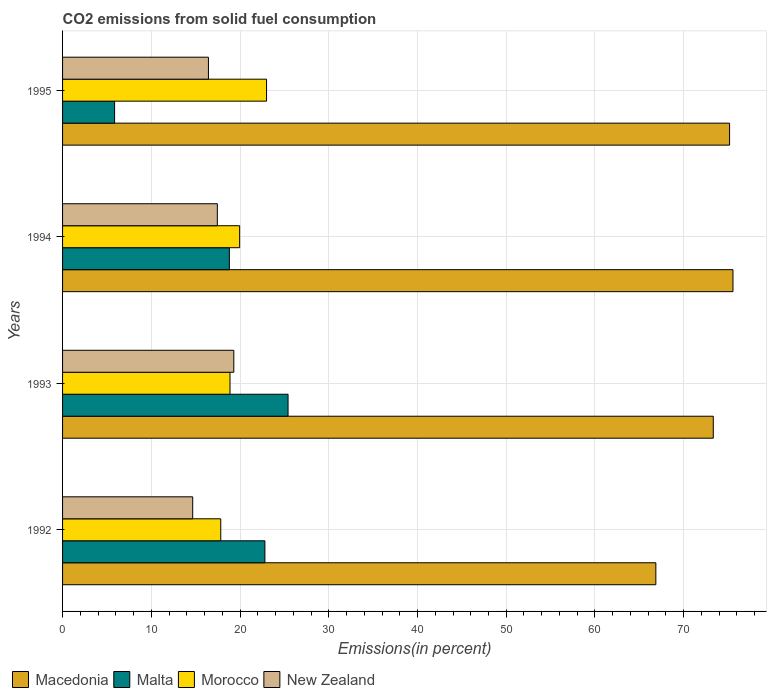How many different coloured bars are there?
Provide a succinct answer. 4. What is the total CO2 emitted in New Zealand in 1992?
Provide a short and direct response. 14.67. Across all years, what is the maximum total CO2 emitted in Morocco?
Provide a short and direct response. 22.99. Across all years, what is the minimum total CO2 emitted in Morocco?
Give a very brief answer. 17.83. In which year was the total CO2 emitted in Morocco minimum?
Your answer should be compact. 1992. What is the total total CO2 emitted in New Zealand in the graph?
Your response must be concise. 67.84. What is the difference between the total CO2 emitted in Morocco in 1993 and that in 1995?
Make the answer very short. -4.12. What is the difference between the total CO2 emitted in Malta in 1994 and the total CO2 emitted in Morocco in 1995?
Make the answer very short. -4.19. What is the average total CO2 emitted in Macedonia per year?
Ensure brevity in your answer.  72.73. In the year 1994, what is the difference between the total CO2 emitted in Morocco and total CO2 emitted in Malta?
Give a very brief answer. 1.16. What is the ratio of the total CO2 emitted in Malta in 1992 to that in 1994?
Your response must be concise. 1.21. What is the difference between the highest and the second highest total CO2 emitted in Morocco?
Your answer should be very brief. 3.03. What is the difference between the highest and the lowest total CO2 emitted in Macedonia?
Your response must be concise. 8.69. In how many years, is the total CO2 emitted in Morocco greater than the average total CO2 emitted in Morocco taken over all years?
Your answer should be compact. 2. Is it the case that in every year, the sum of the total CO2 emitted in Malta and total CO2 emitted in New Zealand is greater than the sum of total CO2 emitted in Morocco and total CO2 emitted in Macedonia?
Give a very brief answer. No. What does the 3rd bar from the top in 1995 represents?
Your response must be concise. Malta. What does the 3rd bar from the bottom in 1992 represents?
Keep it short and to the point. Morocco. How many years are there in the graph?
Give a very brief answer. 4. What is the difference between two consecutive major ticks on the X-axis?
Offer a terse response. 10. Does the graph contain any zero values?
Your answer should be compact. No. How many legend labels are there?
Provide a short and direct response. 4. How are the legend labels stacked?
Give a very brief answer. Horizontal. What is the title of the graph?
Provide a succinct answer. CO2 emissions from solid fuel consumption. Does "Switzerland" appear as one of the legend labels in the graph?
Offer a very short reply. No. What is the label or title of the X-axis?
Your answer should be very brief. Emissions(in percent). What is the Emissions(in percent) of Macedonia in 1992?
Offer a very short reply. 66.86. What is the Emissions(in percent) in Malta in 1992?
Ensure brevity in your answer.  22.8. What is the Emissions(in percent) of Morocco in 1992?
Your response must be concise. 17.83. What is the Emissions(in percent) of New Zealand in 1992?
Keep it short and to the point. 14.67. What is the Emissions(in percent) in Macedonia in 1993?
Provide a succinct answer. 73.33. What is the Emissions(in percent) in Malta in 1993?
Offer a terse response. 25.41. What is the Emissions(in percent) of Morocco in 1993?
Your answer should be very brief. 18.87. What is the Emissions(in percent) in New Zealand in 1993?
Give a very brief answer. 19.3. What is the Emissions(in percent) of Macedonia in 1994?
Give a very brief answer. 75.55. What is the Emissions(in percent) in Malta in 1994?
Provide a succinct answer. 18.8. What is the Emissions(in percent) of Morocco in 1994?
Make the answer very short. 19.96. What is the Emissions(in percent) in New Zealand in 1994?
Your response must be concise. 17.44. What is the Emissions(in percent) of Macedonia in 1995?
Offer a terse response. 75.17. What is the Emissions(in percent) in Malta in 1995?
Offer a terse response. 5.86. What is the Emissions(in percent) in Morocco in 1995?
Ensure brevity in your answer.  22.99. What is the Emissions(in percent) of New Zealand in 1995?
Ensure brevity in your answer.  16.44. Across all years, what is the maximum Emissions(in percent) in Macedonia?
Provide a short and direct response. 75.55. Across all years, what is the maximum Emissions(in percent) of Malta?
Your answer should be compact. 25.41. Across all years, what is the maximum Emissions(in percent) in Morocco?
Your answer should be very brief. 22.99. Across all years, what is the maximum Emissions(in percent) in New Zealand?
Keep it short and to the point. 19.3. Across all years, what is the minimum Emissions(in percent) of Macedonia?
Your response must be concise. 66.86. Across all years, what is the minimum Emissions(in percent) in Malta?
Make the answer very short. 5.86. Across all years, what is the minimum Emissions(in percent) of Morocco?
Your answer should be very brief. 17.83. Across all years, what is the minimum Emissions(in percent) in New Zealand?
Your answer should be compact. 14.67. What is the total Emissions(in percent) in Macedonia in the graph?
Provide a succinct answer. 290.91. What is the total Emissions(in percent) in Malta in the graph?
Offer a terse response. 72.87. What is the total Emissions(in percent) in Morocco in the graph?
Provide a short and direct response. 79.64. What is the total Emissions(in percent) in New Zealand in the graph?
Ensure brevity in your answer.  67.84. What is the difference between the Emissions(in percent) of Macedonia in 1992 and that in 1993?
Provide a short and direct response. -6.47. What is the difference between the Emissions(in percent) in Malta in 1992 and that in 1993?
Offer a terse response. -2.61. What is the difference between the Emissions(in percent) in Morocco in 1992 and that in 1993?
Your response must be concise. -1.04. What is the difference between the Emissions(in percent) of New Zealand in 1992 and that in 1993?
Keep it short and to the point. -4.63. What is the difference between the Emissions(in percent) of Macedonia in 1992 and that in 1994?
Provide a short and direct response. -8.69. What is the difference between the Emissions(in percent) in Malta in 1992 and that in 1994?
Keep it short and to the point. 4. What is the difference between the Emissions(in percent) of Morocco in 1992 and that in 1994?
Offer a very short reply. -2.13. What is the difference between the Emissions(in percent) in New Zealand in 1992 and that in 1994?
Provide a short and direct response. -2.78. What is the difference between the Emissions(in percent) in Macedonia in 1992 and that in 1995?
Give a very brief answer. -8.31. What is the difference between the Emissions(in percent) in Malta in 1992 and that in 1995?
Ensure brevity in your answer.  16.94. What is the difference between the Emissions(in percent) of Morocco in 1992 and that in 1995?
Provide a succinct answer. -5.16. What is the difference between the Emissions(in percent) of New Zealand in 1992 and that in 1995?
Your answer should be compact. -1.77. What is the difference between the Emissions(in percent) of Macedonia in 1993 and that in 1994?
Provide a short and direct response. -2.22. What is the difference between the Emissions(in percent) in Malta in 1993 and that in 1994?
Make the answer very short. 6.62. What is the difference between the Emissions(in percent) in Morocco in 1993 and that in 1994?
Keep it short and to the point. -1.09. What is the difference between the Emissions(in percent) of New Zealand in 1993 and that in 1994?
Offer a very short reply. 1.86. What is the difference between the Emissions(in percent) in Macedonia in 1993 and that in 1995?
Offer a very short reply. -1.84. What is the difference between the Emissions(in percent) in Malta in 1993 and that in 1995?
Provide a short and direct response. 19.55. What is the difference between the Emissions(in percent) in Morocco in 1993 and that in 1995?
Your answer should be compact. -4.12. What is the difference between the Emissions(in percent) of New Zealand in 1993 and that in 1995?
Ensure brevity in your answer.  2.86. What is the difference between the Emissions(in percent) of Macedonia in 1994 and that in 1995?
Provide a short and direct response. 0.38. What is the difference between the Emissions(in percent) in Malta in 1994 and that in 1995?
Ensure brevity in your answer.  12.93. What is the difference between the Emissions(in percent) in Morocco in 1994 and that in 1995?
Give a very brief answer. -3.03. What is the difference between the Emissions(in percent) in Macedonia in 1992 and the Emissions(in percent) in Malta in 1993?
Offer a terse response. 41.45. What is the difference between the Emissions(in percent) in Macedonia in 1992 and the Emissions(in percent) in Morocco in 1993?
Your answer should be very brief. 47.99. What is the difference between the Emissions(in percent) in Macedonia in 1992 and the Emissions(in percent) in New Zealand in 1993?
Provide a short and direct response. 47.56. What is the difference between the Emissions(in percent) in Malta in 1992 and the Emissions(in percent) in Morocco in 1993?
Provide a short and direct response. 3.93. What is the difference between the Emissions(in percent) of Malta in 1992 and the Emissions(in percent) of New Zealand in 1993?
Your response must be concise. 3.5. What is the difference between the Emissions(in percent) in Morocco in 1992 and the Emissions(in percent) in New Zealand in 1993?
Your answer should be very brief. -1.47. What is the difference between the Emissions(in percent) in Macedonia in 1992 and the Emissions(in percent) in Malta in 1994?
Your response must be concise. 48.06. What is the difference between the Emissions(in percent) of Macedonia in 1992 and the Emissions(in percent) of Morocco in 1994?
Keep it short and to the point. 46.9. What is the difference between the Emissions(in percent) in Macedonia in 1992 and the Emissions(in percent) in New Zealand in 1994?
Offer a very short reply. 49.42. What is the difference between the Emissions(in percent) in Malta in 1992 and the Emissions(in percent) in Morocco in 1994?
Keep it short and to the point. 2.85. What is the difference between the Emissions(in percent) of Malta in 1992 and the Emissions(in percent) of New Zealand in 1994?
Provide a succinct answer. 5.36. What is the difference between the Emissions(in percent) of Morocco in 1992 and the Emissions(in percent) of New Zealand in 1994?
Your response must be concise. 0.39. What is the difference between the Emissions(in percent) of Macedonia in 1992 and the Emissions(in percent) of Malta in 1995?
Provide a succinct answer. 61. What is the difference between the Emissions(in percent) in Macedonia in 1992 and the Emissions(in percent) in Morocco in 1995?
Your answer should be compact. 43.87. What is the difference between the Emissions(in percent) of Macedonia in 1992 and the Emissions(in percent) of New Zealand in 1995?
Offer a terse response. 50.42. What is the difference between the Emissions(in percent) in Malta in 1992 and the Emissions(in percent) in Morocco in 1995?
Offer a terse response. -0.19. What is the difference between the Emissions(in percent) of Malta in 1992 and the Emissions(in percent) of New Zealand in 1995?
Make the answer very short. 6.36. What is the difference between the Emissions(in percent) in Morocco in 1992 and the Emissions(in percent) in New Zealand in 1995?
Offer a very short reply. 1.39. What is the difference between the Emissions(in percent) in Macedonia in 1993 and the Emissions(in percent) in Malta in 1994?
Make the answer very short. 54.54. What is the difference between the Emissions(in percent) of Macedonia in 1993 and the Emissions(in percent) of Morocco in 1994?
Keep it short and to the point. 53.38. What is the difference between the Emissions(in percent) in Macedonia in 1993 and the Emissions(in percent) in New Zealand in 1994?
Offer a very short reply. 55.89. What is the difference between the Emissions(in percent) in Malta in 1993 and the Emissions(in percent) in Morocco in 1994?
Give a very brief answer. 5.46. What is the difference between the Emissions(in percent) of Malta in 1993 and the Emissions(in percent) of New Zealand in 1994?
Your response must be concise. 7.97. What is the difference between the Emissions(in percent) in Morocco in 1993 and the Emissions(in percent) in New Zealand in 1994?
Ensure brevity in your answer.  1.43. What is the difference between the Emissions(in percent) of Macedonia in 1993 and the Emissions(in percent) of Malta in 1995?
Give a very brief answer. 67.47. What is the difference between the Emissions(in percent) of Macedonia in 1993 and the Emissions(in percent) of Morocco in 1995?
Your response must be concise. 50.35. What is the difference between the Emissions(in percent) of Macedonia in 1993 and the Emissions(in percent) of New Zealand in 1995?
Make the answer very short. 56.89. What is the difference between the Emissions(in percent) in Malta in 1993 and the Emissions(in percent) in Morocco in 1995?
Keep it short and to the point. 2.43. What is the difference between the Emissions(in percent) of Malta in 1993 and the Emissions(in percent) of New Zealand in 1995?
Your response must be concise. 8.97. What is the difference between the Emissions(in percent) in Morocco in 1993 and the Emissions(in percent) in New Zealand in 1995?
Provide a succinct answer. 2.43. What is the difference between the Emissions(in percent) of Macedonia in 1994 and the Emissions(in percent) of Malta in 1995?
Ensure brevity in your answer.  69.69. What is the difference between the Emissions(in percent) in Macedonia in 1994 and the Emissions(in percent) in Morocco in 1995?
Give a very brief answer. 52.56. What is the difference between the Emissions(in percent) of Macedonia in 1994 and the Emissions(in percent) of New Zealand in 1995?
Make the answer very short. 59.11. What is the difference between the Emissions(in percent) of Malta in 1994 and the Emissions(in percent) of Morocco in 1995?
Your response must be concise. -4.19. What is the difference between the Emissions(in percent) in Malta in 1994 and the Emissions(in percent) in New Zealand in 1995?
Provide a succinct answer. 2.36. What is the difference between the Emissions(in percent) of Morocco in 1994 and the Emissions(in percent) of New Zealand in 1995?
Provide a succinct answer. 3.52. What is the average Emissions(in percent) of Macedonia per year?
Make the answer very short. 72.73. What is the average Emissions(in percent) in Malta per year?
Offer a terse response. 18.22. What is the average Emissions(in percent) of Morocco per year?
Keep it short and to the point. 19.91. What is the average Emissions(in percent) in New Zealand per year?
Keep it short and to the point. 16.96. In the year 1992, what is the difference between the Emissions(in percent) of Macedonia and Emissions(in percent) of Malta?
Offer a terse response. 44.06. In the year 1992, what is the difference between the Emissions(in percent) in Macedonia and Emissions(in percent) in Morocco?
Provide a short and direct response. 49.03. In the year 1992, what is the difference between the Emissions(in percent) of Macedonia and Emissions(in percent) of New Zealand?
Keep it short and to the point. 52.19. In the year 1992, what is the difference between the Emissions(in percent) of Malta and Emissions(in percent) of Morocco?
Ensure brevity in your answer.  4.97. In the year 1992, what is the difference between the Emissions(in percent) in Malta and Emissions(in percent) in New Zealand?
Offer a very short reply. 8.14. In the year 1992, what is the difference between the Emissions(in percent) in Morocco and Emissions(in percent) in New Zealand?
Your answer should be compact. 3.16. In the year 1993, what is the difference between the Emissions(in percent) of Macedonia and Emissions(in percent) of Malta?
Your answer should be compact. 47.92. In the year 1993, what is the difference between the Emissions(in percent) of Macedonia and Emissions(in percent) of Morocco?
Provide a succinct answer. 54.46. In the year 1993, what is the difference between the Emissions(in percent) of Macedonia and Emissions(in percent) of New Zealand?
Your answer should be very brief. 54.03. In the year 1993, what is the difference between the Emissions(in percent) of Malta and Emissions(in percent) of Morocco?
Your answer should be compact. 6.54. In the year 1993, what is the difference between the Emissions(in percent) of Malta and Emissions(in percent) of New Zealand?
Make the answer very short. 6.11. In the year 1993, what is the difference between the Emissions(in percent) of Morocco and Emissions(in percent) of New Zealand?
Offer a terse response. -0.43. In the year 1994, what is the difference between the Emissions(in percent) in Macedonia and Emissions(in percent) in Malta?
Offer a terse response. 56.75. In the year 1994, what is the difference between the Emissions(in percent) in Macedonia and Emissions(in percent) in Morocco?
Give a very brief answer. 55.6. In the year 1994, what is the difference between the Emissions(in percent) of Macedonia and Emissions(in percent) of New Zealand?
Make the answer very short. 58.11. In the year 1994, what is the difference between the Emissions(in percent) in Malta and Emissions(in percent) in Morocco?
Ensure brevity in your answer.  -1.16. In the year 1994, what is the difference between the Emissions(in percent) of Malta and Emissions(in percent) of New Zealand?
Provide a succinct answer. 1.36. In the year 1994, what is the difference between the Emissions(in percent) of Morocco and Emissions(in percent) of New Zealand?
Provide a succinct answer. 2.52. In the year 1995, what is the difference between the Emissions(in percent) in Macedonia and Emissions(in percent) in Malta?
Offer a very short reply. 69.31. In the year 1995, what is the difference between the Emissions(in percent) in Macedonia and Emissions(in percent) in Morocco?
Give a very brief answer. 52.18. In the year 1995, what is the difference between the Emissions(in percent) in Macedonia and Emissions(in percent) in New Zealand?
Your answer should be compact. 58.73. In the year 1995, what is the difference between the Emissions(in percent) of Malta and Emissions(in percent) of Morocco?
Offer a very short reply. -17.12. In the year 1995, what is the difference between the Emissions(in percent) in Malta and Emissions(in percent) in New Zealand?
Offer a very short reply. -10.58. In the year 1995, what is the difference between the Emissions(in percent) of Morocco and Emissions(in percent) of New Zealand?
Provide a succinct answer. 6.55. What is the ratio of the Emissions(in percent) of Macedonia in 1992 to that in 1993?
Give a very brief answer. 0.91. What is the ratio of the Emissions(in percent) of Malta in 1992 to that in 1993?
Your response must be concise. 0.9. What is the ratio of the Emissions(in percent) of Morocco in 1992 to that in 1993?
Make the answer very short. 0.94. What is the ratio of the Emissions(in percent) of New Zealand in 1992 to that in 1993?
Your answer should be very brief. 0.76. What is the ratio of the Emissions(in percent) in Macedonia in 1992 to that in 1994?
Provide a succinct answer. 0.89. What is the ratio of the Emissions(in percent) of Malta in 1992 to that in 1994?
Your response must be concise. 1.21. What is the ratio of the Emissions(in percent) of Morocco in 1992 to that in 1994?
Your response must be concise. 0.89. What is the ratio of the Emissions(in percent) in New Zealand in 1992 to that in 1994?
Keep it short and to the point. 0.84. What is the ratio of the Emissions(in percent) of Macedonia in 1992 to that in 1995?
Your answer should be compact. 0.89. What is the ratio of the Emissions(in percent) in Malta in 1992 to that in 1995?
Ensure brevity in your answer.  3.89. What is the ratio of the Emissions(in percent) of Morocco in 1992 to that in 1995?
Keep it short and to the point. 0.78. What is the ratio of the Emissions(in percent) of New Zealand in 1992 to that in 1995?
Your response must be concise. 0.89. What is the ratio of the Emissions(in percent) of Macedonia in 1993 to that in 1994?
Offer a very short reply. 0.97. What is the ratio of the Emissions(in percent) in Malta in 1993 to that in 1994?
Offer a very short reply. 1.35. What is the ratio of the Emissions(in percent) in Morocco in 1993 to that in 1994?
Your response must be concise. 0.95. What is the ratio of the Emissions(in percent) of New Zealand in 1993 to that in 1994?
Make the answer very short. 1.11. What is the ratio of the Emissions(in percent) of Macedonia in 1993 to that in 1995?
Your response must be concise. 0.98. What is the ratio of the Emissions(in percent) of Malta in 1993 to that in 1995?
Your answer should be compact. 4.33. What is the ratio of the Emissions(in percent) of Morocco in 1993 to that in 1995?
Give a very brief answer. 0.82. What is the ratio of the Emissions(in percent) of New Zealand in 1993 to that in 1995?
Ensure brevity in your answer.  1.17. What is the ratio of the Emissions(in percent) in Macedonia in 1994 to that in 1995?
Make the answer very short. 1.01. What is the ratio of the Emissions(in percent) in Malta in 1994 to that in 1995?
Make the answer very short. 3.21. What is the ratio of the Emissions(in percent) of Morocco in 1994 to that in 1995?
Keep it short and to the point. 0.87. What is the ratio of the Emissions(in percent) in New Zealand in 1994 to that in 1995?
Give a very brief answer. 1.06. What is the difference between the highest and the second highest Emissions(in percent) of Macedonia?
Your response must be concise. 0.38. What is the difference between the highest and the second highest Emissions(in percent) of Malta?
Make the answer very short. 2.61. What is the difference between the highest and the second highest Emissions(in percent) in Morocco?
Ensure brevity in your answer.  3.03. What is the difference between the highest and the second highest Emissions(in percent) of New Zealand?
Your answer should be very brief. 1.86. What is the difference between the highest and the lowest Emissions(in percent) in Macedonia?
Keep it short and to the point. 8.69. What is the difference between the highest and the lowest Emissions(in percent) in Malta?
Provide a succinct answer. 19.55. What is the difference between the highest and the lowest Emissions(in percent) in Morocco?
Keep it short and to the point. 5.16. What is the difference between the highest and the lowest Emissions(in percent) in New Zealand?
Your answer should be very brief. 4.63. 